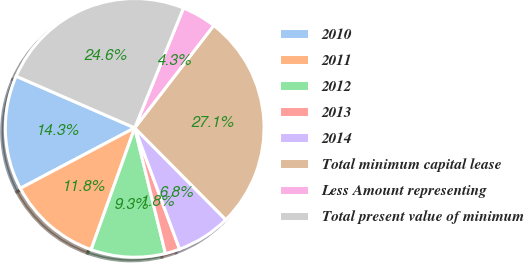Convert chart. <chart><loc_0><loc_0><loc_500><loc_500><pie_chart><fcel>2010<fcel>2011<fcel>2012<fcel>2013<fcel>2014<fcel>Total minimum capital lease<fcel>Less Amount representing<fcel>Total present value of minimum<nl><fcel>14.28%<fcel>11.79%<fcel>9.29%<fcel>1.82%<fcel>6.8%<fcel>27.1%<fcel>4.31%<fcel>24.61%<nl></chart> 